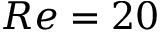Convert formula to latex. <formula><loc_0><loc_0><loc_500><loc_500>R e = 2 0</formula> 